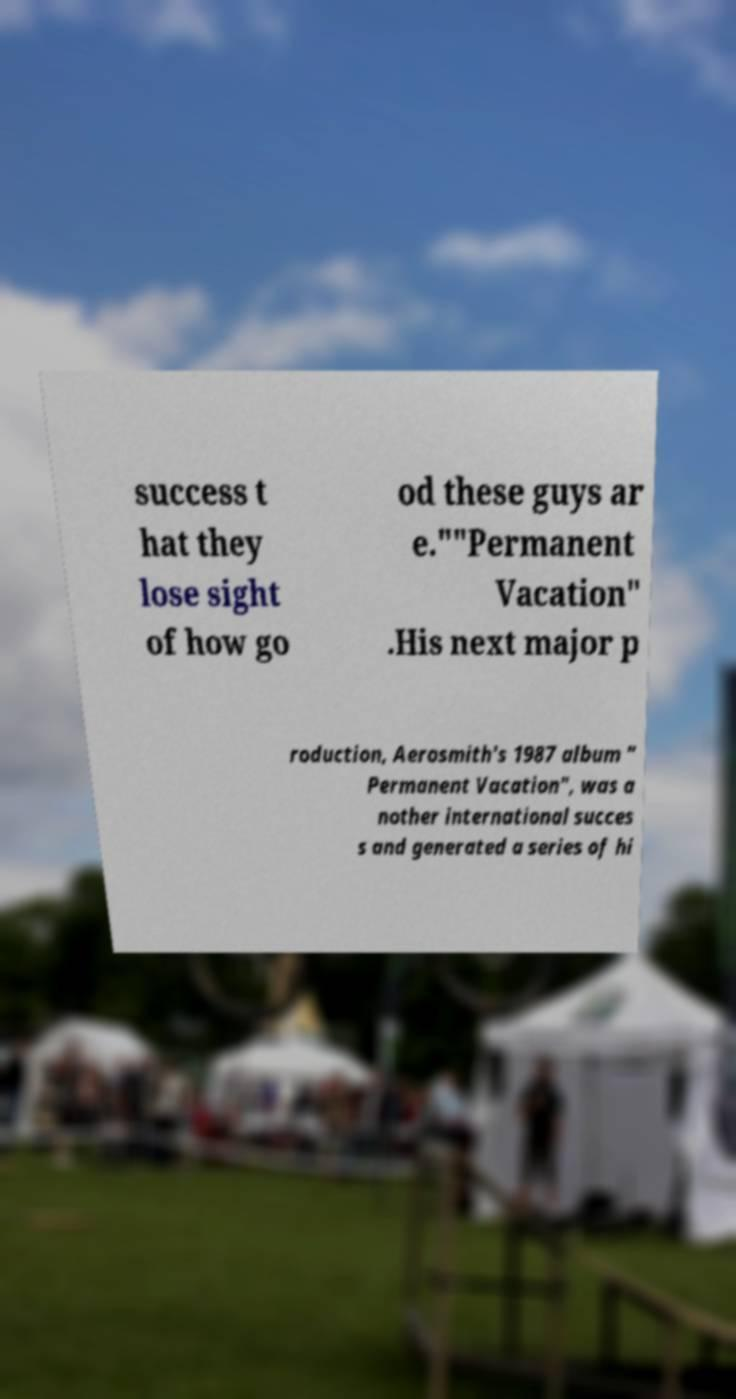I need the written content from this picture converted into text. Can you do that? success t hat they lose sight of how go od these guys ar e.""Permanent Vacation" .His next major p roduction, Aerosmith's 1987 album " Permanent Vacation", was a nother international succes s and generated a series of hi 